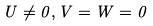Convert formula to latex. <formula><loc_0><loc_0><loc_500><loc_500>U \ne 0 , V = W = 0</formula> 